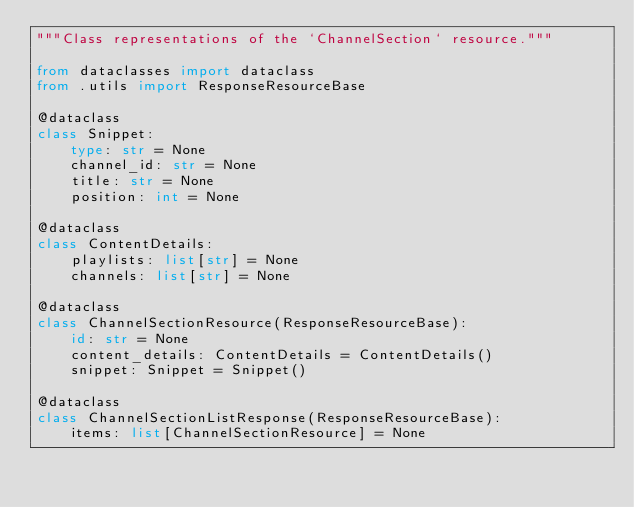Convert code to text. <code><loc_0><loc_0><loc_500><loc_500><_Python_>"""Class representations of the `ChannelSection` resource."""

from dataclasses import dataclass
from .utils import ResponseResourceBase

@dataclass
class Snippet:
    type: str = None
    channel_id: str = None
    title: str = None
    position: int = None
    
@dataclass
class ContentDetails:
    playlists: list[str] = None
    channels: list[str] = None
    
@dataclass
class ChannelSectionResource(ResponseResourceBase):
    id: str = None
    content_details: ContentDetails = ContentDetails()
    snippet: Snippet = Snippet()
    
@dataclass
class ChannelSectionListResponse(ResponseResourceBase):
    items: list[ChannelSectionResource] = None</code> 